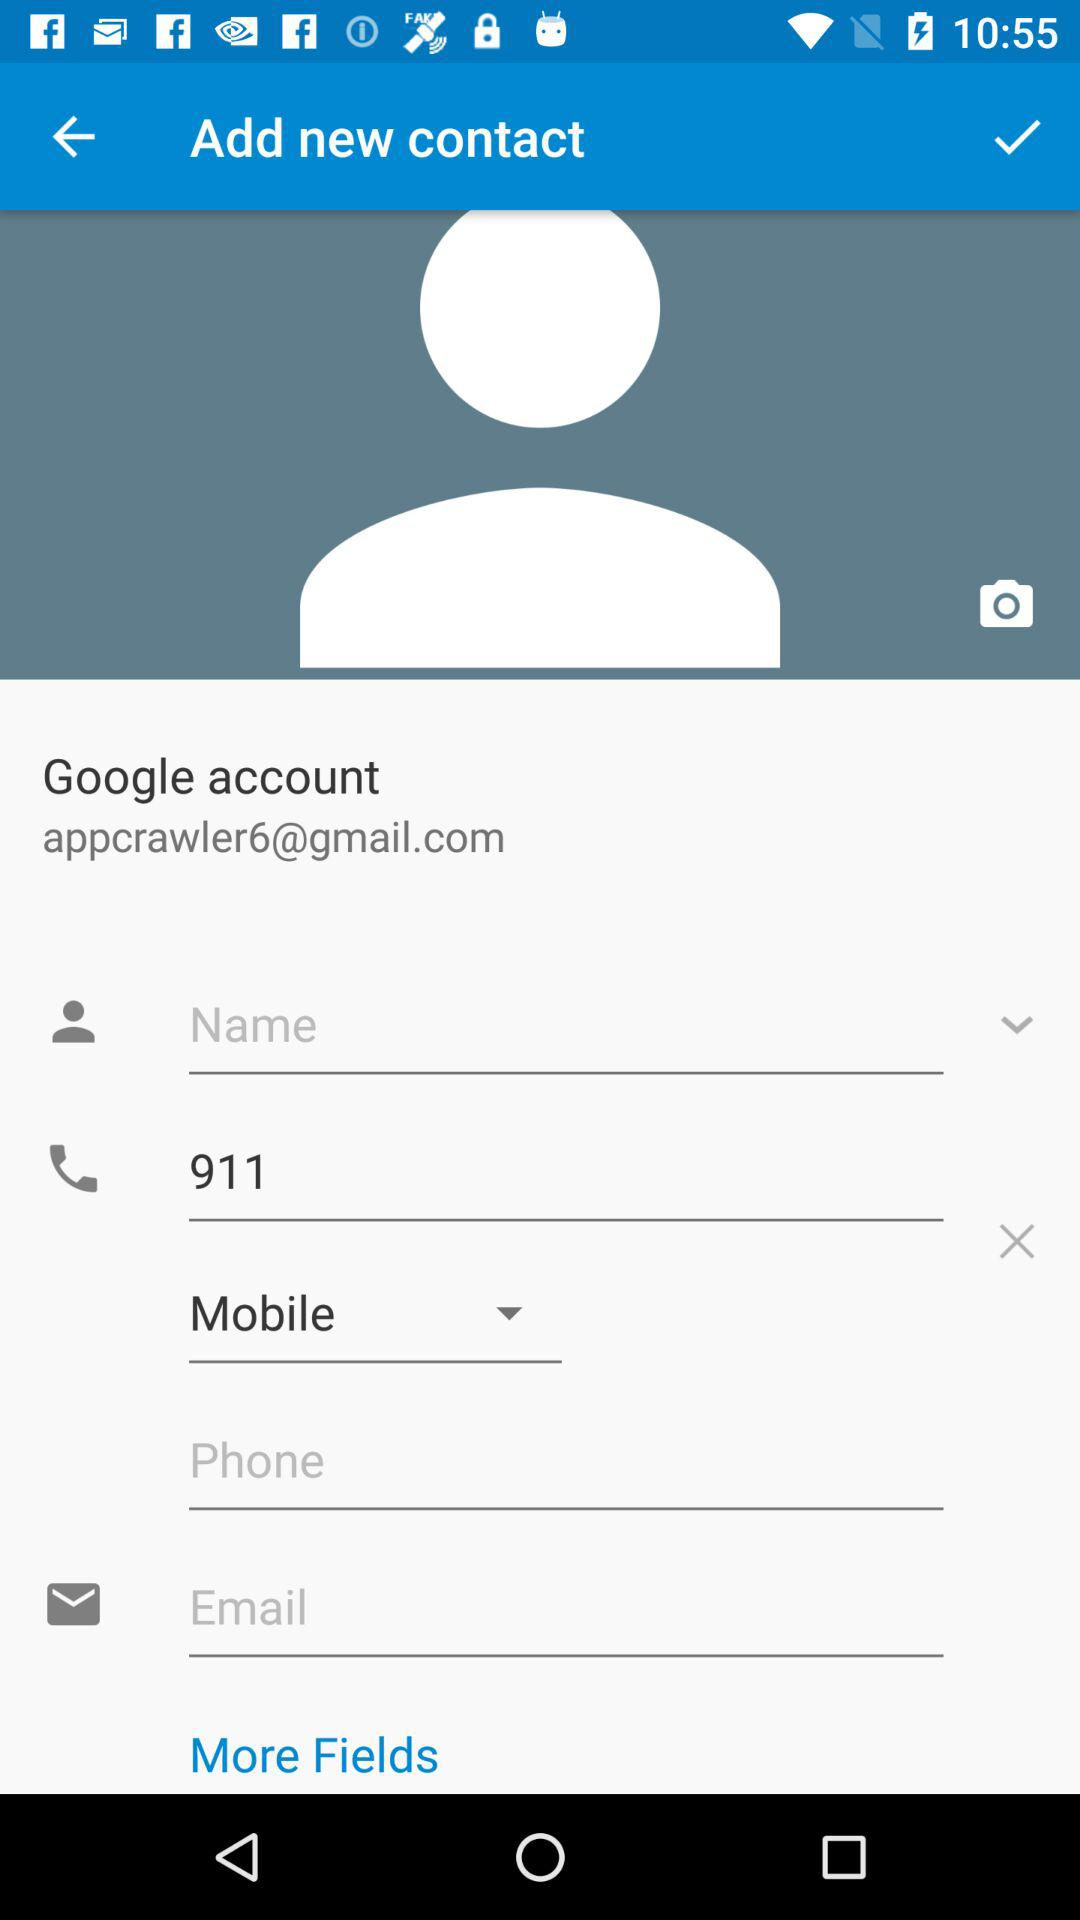What is the email address? The email address is appcrawler6@gmail.com. 